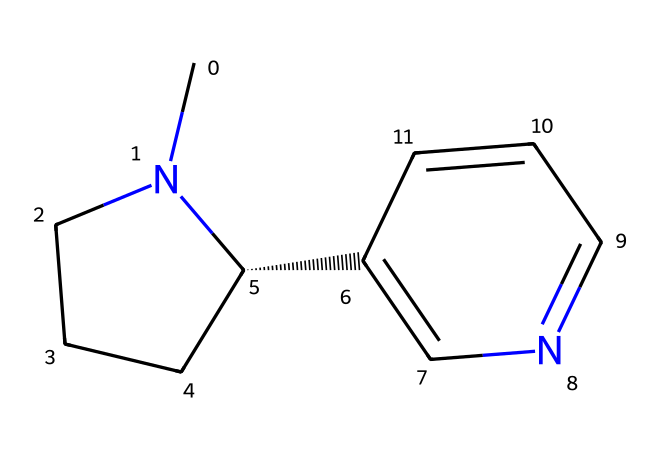What is the molecular formula of nicotine? To determine the molecular formula, we analyze the SMILES representation. The structure shows two nitrogen atoms, ten carbon atoms, and fourteen hydrogen atoms, resulting in the formula C10H14N2.
Answer: C10H14N2 How many rings are present in the nicotine structure? By examining the SMILES notation, we note that there are two ring structures present: one is a piperidine ring and the other is a pyridine ring.
Answer: two What is the functional group associated with nicotine? The presence of nitrogen atoms in the SMILES structure indicates the functional group. Nicotine contains both a pyridine and a piperidine component, hence it can be classified as a nitrogen-containing base, typical of alkaloids.
Answer: alkaloid What type of bonding is predominant in nicotine? Evaluating the SMILES structure, we see that it consists predominantly of single bonds (between carbon and hydrogen) and also includes double bonds between carbon and nitrogen in the ring structure. This diverse bonding type is characteristic of organic compounds.
Answer: single and double bonds Does nicotine contain a stereocenter? In the provided SMILES, we identify the "C@H" which indicates a chiral carbon atom. This presence confirms that the structure indeed has a stereocenter.
Answer: yes What is the primary biological activity of nicotine? Nicotine is primarily known for its stimulant properties, affecting the central nervous system by binding to nicotinic acetylcholine receptors, which mimics the neurotransmitter acetylcholine.
Answer: stimulant How does the structure of nicotine contribute to its addictive nature? The presence of the nitrogen atoms in the rings facilitates binding to the nicotinic receptors in the brain, which is a key factor in the addictive properties of nicotine. This structural characteristic allows for a strong interaction with biological targets.
Answer: binding to receptors 